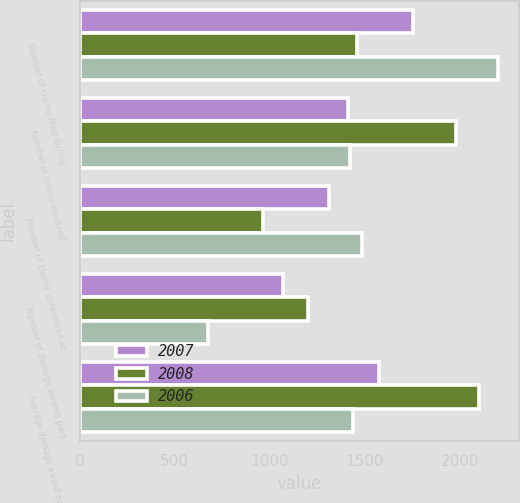<chart> <loc_0><loc_0><loc_500><loc_500><stacked_bar_chart><ecel><fcel>Number of claims filed during<fcel>Number of claims resolved<fcel>Number of claims unresolved at<fcel>Number of damage awards paid<fcel>Average damage award paid<nl><fcel>2007<fcel>1755<fcel>1410<fcel>1310<fcel>1070<fcel>1574<nl><fcel>2008<fcel>1460<fcel>1980<fcel>965<fcel>1200<fcel>2100<nl><fcel>2006<fcel>2200<fcel>1420<fcel>1485<fcel>675<fcel>1440<nl></chart> 